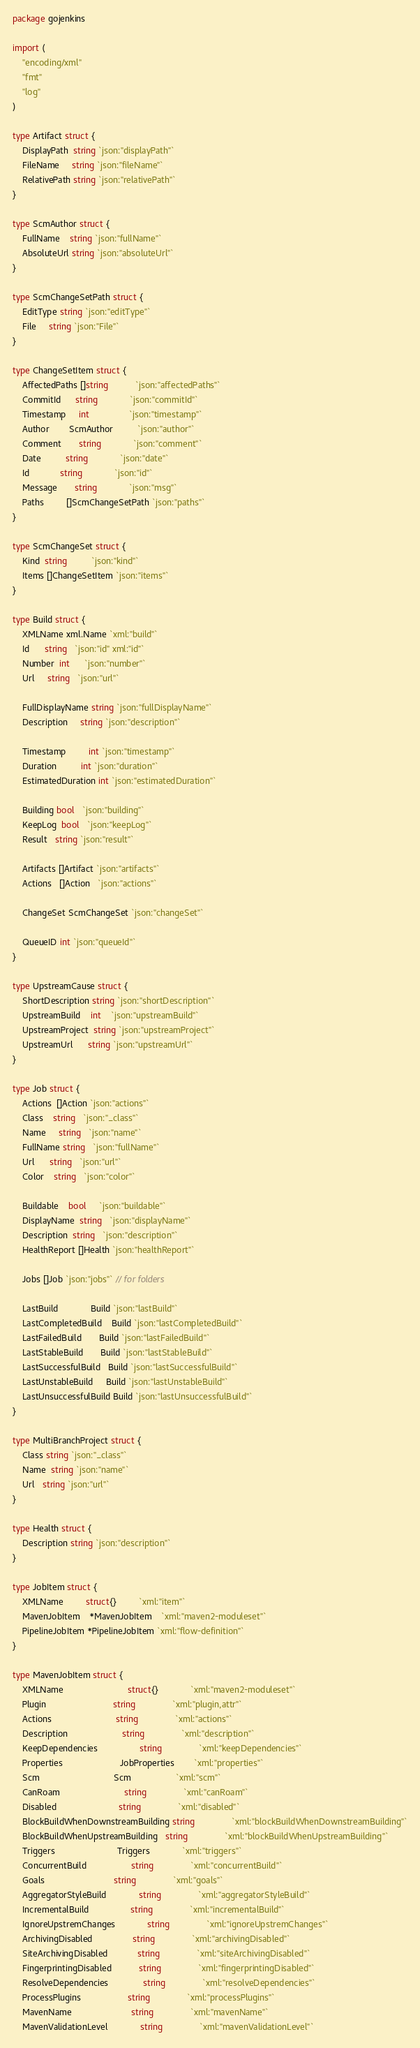Convert code to text. <code><loc_0><loc_0><loc_500><loc_500><_Go_>package gojenkins

import (
	"encoding/xml"
	"fmt"
	"log"
)

type Artifact struct {
	DisplayPath  string `json:"displayPath"`
	FileName     string `json:"fileName"`
	RelativePath string `json:"relativePath"`
}

type ScmAuthor struct {
	FullName    string `json:"fullName"`
	AbsoluteUrl string `json:"absoluteUrl"`
}

type ScmChangeSetPath struct {
	EditType string `json:"editType"`
	File     string `json:"File"`
}

type ChangeSetItem struct {
	AffectedPaths []string           `json:"affectedPaths"`
	CommitId      string             `json:"commitId"`
	Timestamp     int                `json:"timestamp"`
	Author        ScmAuthor          `json:"author"`
	Comment       string             `json:"comment"`
	Date          string             `json:"date"`
	Id            string             `json:"id"`
	Message       string             `json:"msg"`
	Paths         []ScmChangeSetPath `json:"paths"`
}

type ScmChangeSet struct {
	Kind  string          `json:"kind"`
	Items []ChangeSetItem `json:"items"`
}

type Build struct {
	XMLName xml.Name `xml:"build"`
	Id      string   `json:"id" xml:"id"`
	Number  int      `json:"number"`
	Url     string   `json:"url"`

	FullDisplayName string `json:"fullDisplayName"`
	Description     string `json:"description"`

	Timestamp         int `json:"timestamp"`
	Duration          int `json:"duration"`
	EstimatedDuration int `json:"estimatedDuration"`

	Building bool   `json:"building"`
	KeepLog  bool   `json:"keepLog"`
	Result   string `json:"result"`

	Artifacts []Artifact `json:"artifacts"`
	Actions   []Action   `json:"actions"`

	ChangeSet ScmChangeSet `json:"changeSet"`

	QueueID int `json:"queueId"`
}

type UpstreamCause struct {
	ShortDescription string `json:"shortDescription"`
	UpstreamBuild    int    `json:"upstreamBuild"`
	UpstreamProject  string `json:"upstreamProject"`
	UpstreamUrl      string `json:"upstreamUrl"`
}

type Job struct {
	Actions  []Action `json:"actions"`
	Class    string   `json:"_class"`
	Name     string   `json:"name"`
	FullName string   `json:"fullName"`
	Url      string   `json:"url"`
	Color    string   `json:"color"`

	Buildable    bool     `json:"buildable"`
	DisplayName  string   `json:"displayName"`
	Description  string   `json:"description"`
	HealthReport []Health `json:"healthReport"`

	Jobs []Job `json:"jobs"` // for folders

	LastBuild             Build `json:"lastBuild"`
	LastCompletedBuild    Build `json:"lastCompletedBuild"`
	LastFailedBuild       Build `json:"lastFailedBuild"`
	LastStableBuild       Build `json:"lastStableBuild"`
	LastSuccessfulBuild   Build `json:"lastSuccessfulBuild"`
	LastUnstableBuild     Build `json:"lastUnstableBuild"`
	LastUnsuccessfulBuild Build `json:"lastUnsuccessfulBuild"`
}

type MultiBranchProject struct {
	Class string `json:"_class"`
	Name  string `json:"name"`
	Url   string `json:"url"`
}

type Health struct {
	Description string `json:"description"`
}

type JobItem struct {
	XMLName         struct{}         `xml:"item"`
	MavenJobItem    *MavenJobItem    `xml:"maven2-moduleset"`
	PipelineJobItem *PipelineJobItem `xml:"flow-definition"`
}

type MavenJobItem struct {
	XMLName                          struct{}             `xml:"maven2-moduleset"`
	Plugin                           string               `xml:"plugin,attr"`
	Actions                          string               `xml:"actions"`
	Description                      string               `xml:"description"`
	KeepDependencies                 string               `xml:"keepDependencies"`
	Properties                       JobProperties        `xml:"properties"`
	Scm                              Scm                  `xml:"scm"`
	CanRoam                          string               `xml:"canRoam"`
	Disabled                         string               `xml:"disabled"`
	BlockBuildWhenDownstreamBuilding string               `xml:"blockBuildWhenDownstreamBuilding"`
	BlockBuildWhenUpstreamBuilding   string               `xml:"blockBuildWhenUpstreamBuilding"`
	Triggers                         Triggers             `xml:"triggers"`
	ConcurrentBuild                  string               `xml:"concurrentBuild"`
	Goals                            string               `xml:"goals"`
	AggregatorStyleBuild             string               `xml:"aggregatorStyleBuild"`
	IncrementalBuild                 string               `xml:"incrementalBuild"`
	IgnoreUpstremChanges             string               `xml:"ignoreUpstremChanges"`
	ArchivingDisabled                string               `xml:"archivingDisabled"`
	SiteArchivingDisabled            string               `xml:"siteArchivingDisabled"`
	FingerprintingDisabled           string               `xml:"fingerprintingDisabled"`
	ResolveDependencies              string               `xml:"resolveDependencies"`
	ProcessPlugins                   string               `xml:"processPlugins"`
	MavenName                        string               `xml:"mavenName"`
	MavenValidationLevel             string               `xml:"mavenValidationLevel"`</code> 